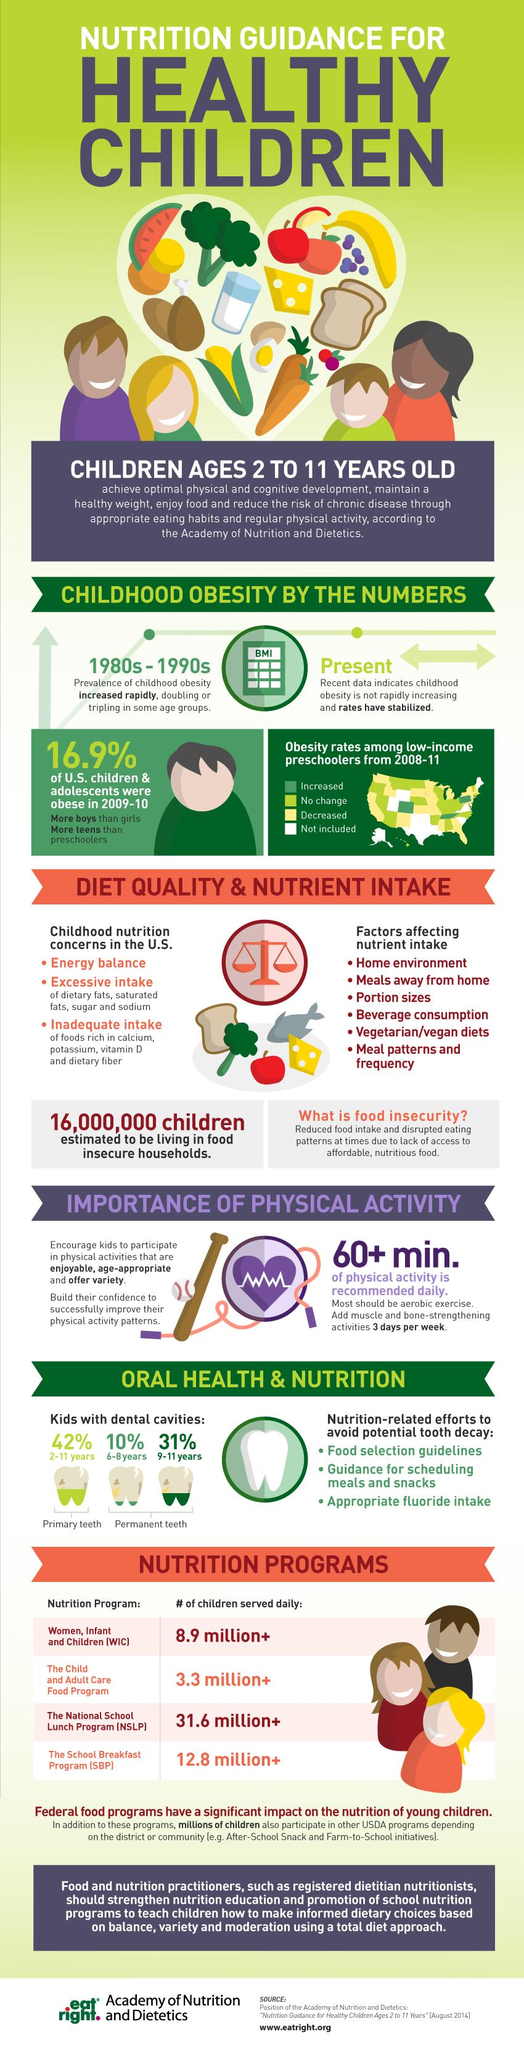List a handful of essential elements in this visual. During the 1980s and 1990s, there was a rapid increase in cases of childhood obesity. The third factor that affects nutrient intake is portion sizes. Foods that are rich in calcium, potassium, vitamin D, and dietary fiber are often consumed in inadequate amounts, leading to potential nutrient deficiencies. Approximately 42% of children have cavities in their primary teeth. The number of factors affecting nutrient intake that have been listed is six. 